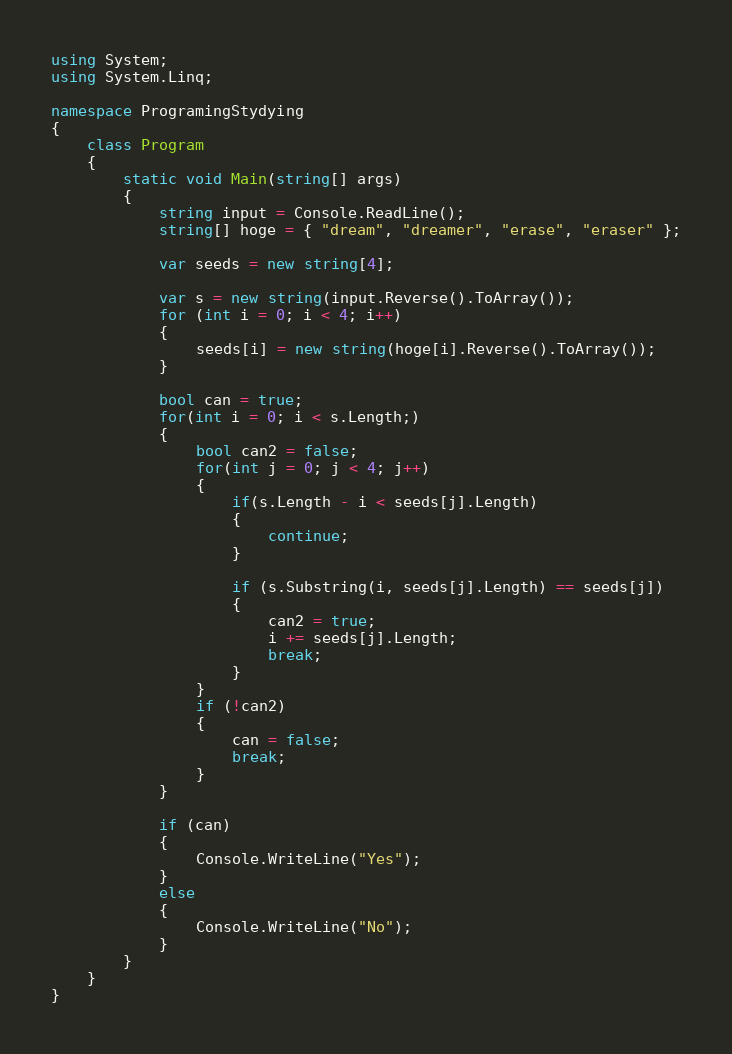Convert code to text. <code><loc_0><loc_0><loc_500><loc_500><_C#_>using System;
using System.Linq;

namespace ProgramingStydying
{
    class Program
    {
        static void Main(string[] args)
        {
            string input = Console.ReadLine();
            string[] hoge = { "dream", "dreamer", "erase", "eraser" };

            var seeds = new string[4];

            var s = new string(input.Reverse().ToArray());
            for (int i = 0; i < 4; i++)
            {
                seeds[i] = new string(hoge[i].Reverse().ToArray());
            }

            bool can = true;
            for(int i = 0; i < s.Length;)
            {
                bool can2 = false;
                for(int j = 0; j < 4; j++)
                {
                    if(s.Length - i < seeds[j].Length)
                    {
                        continue;
                    }

                    if (s.Substring(i, seeds[j].Length) == seeds[j])
                    {
                        can2 = true;
                        i += seeds[j].Length;
                        break;
                    }
                }
                if (!can2)
                {
                    can = false;
                    break;
                }
            }

            if (can)
            {
                Console.WriteLine("Yes");
            }
            else
            {
                Console.WriteLine("No");
            }
        }
    }
}</code> 